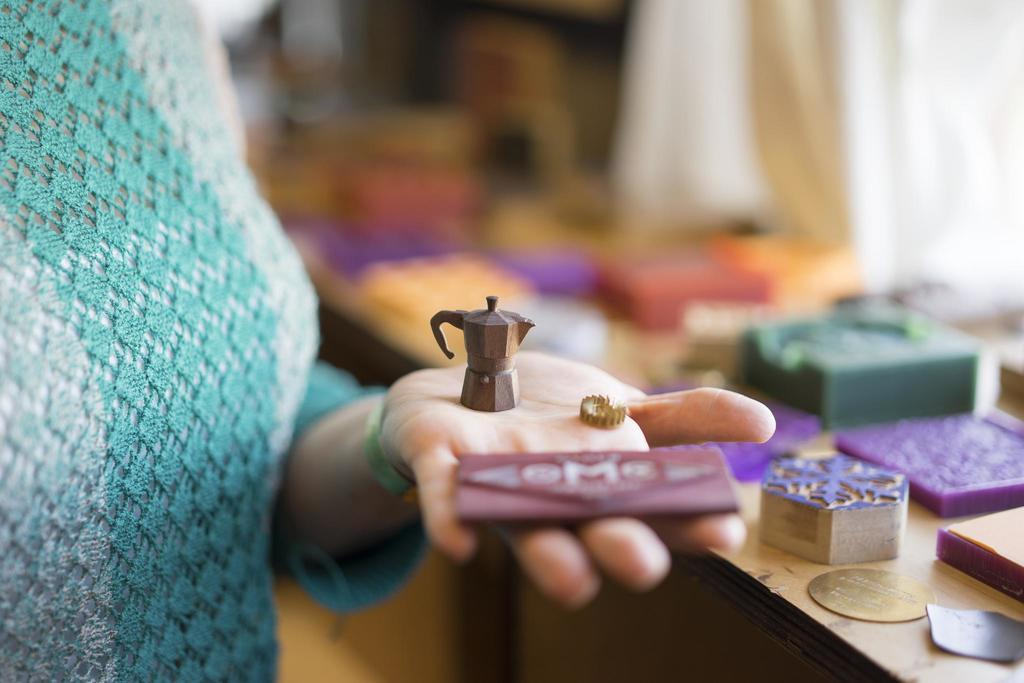What part of the human body is visible in the image? There is a human hand in the image. What else can be seen in the image besides the hand? There are objects and cloth visible in the image. Can you describe the background of the image? The background of the image is blurred. How many fish are swimming in the image? There are no fish present in the image. 